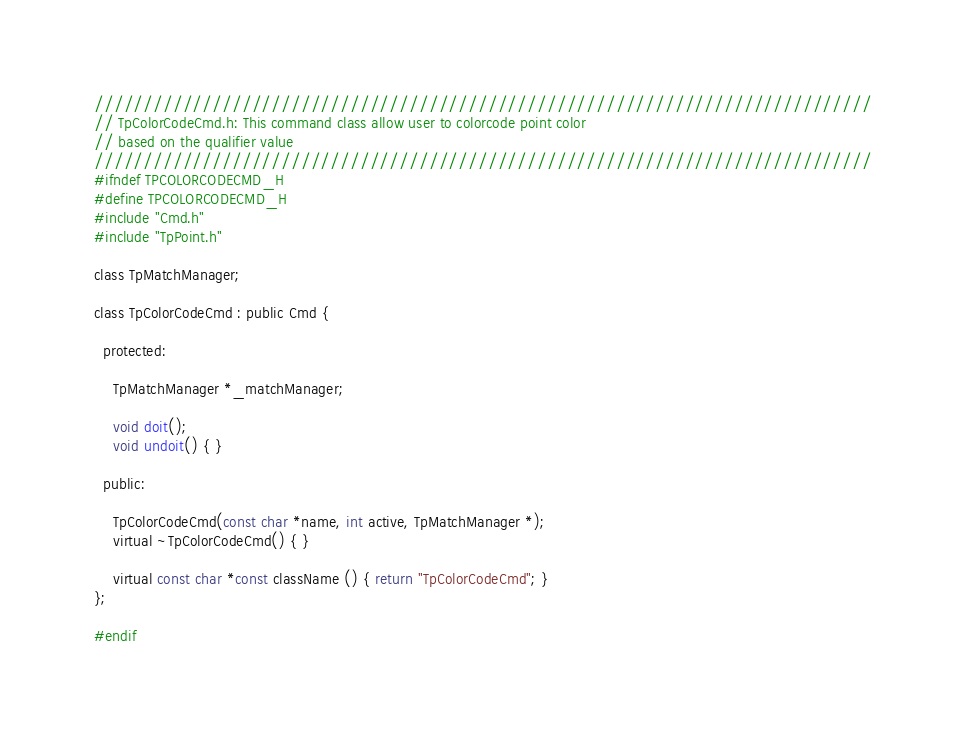<code> <loc_0><loc_0><loc_500><loc_500><_C_>///////////////////////////////////////////////////////////////////////////////
// TpColorCodeCmd.h: This command class allow user to colorcode point color 
// based on the qualifier value
///////////////////////////////////////////////////////////////////////////////
#ifndef TPCOLORCODECMD_H
#define TPCOLORCODECMD_H
#include "Cmd.h"
#include "TpPoint.h"

class TpMatchManager;

class TpColorCodeCmd : public Cmd {

  protected:

    TpMatchManager *_matchManager;

    void doit();
    void undoit() { }

  public:

    TpColorCodeCmd(const char *name, int active, TpMatchManager *);
    virtual ~TpColorCodeCmd() { }

    virtual const char *const className () { return "TpColorCodeCmd"; }
};

#endif
</code> 